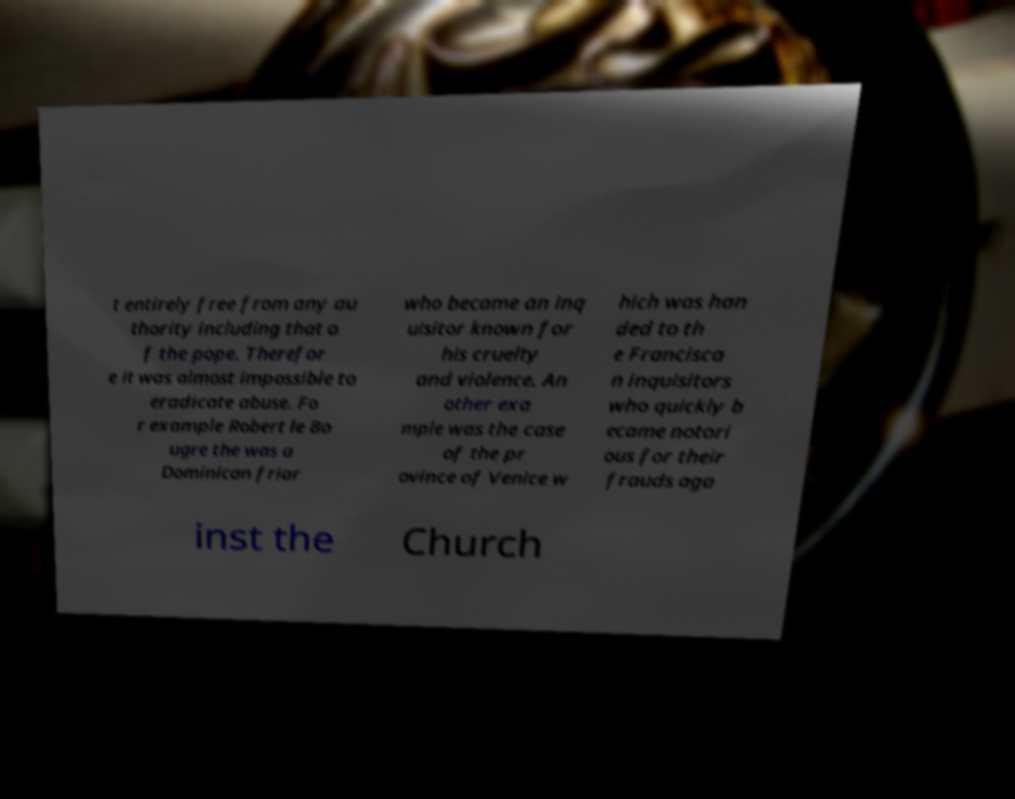Can you read and provide the text displayed in the image?This photo seems to have some interesting text. Can you extract and type it out for me? t entirely free from any au thority including that o f the pope. Therefor e it was almost impossible to eradicate abuse. Fo r example Robert le Bo ugre the was a Dominican friar who became an inq uisitor known for his cruelty and violence. An other exa mple was the case of the pr ovince of Venice w hich was han ded to th e Francisca n inquisitors who quickly b ecame notori ous for their frauds aga inst the Church 